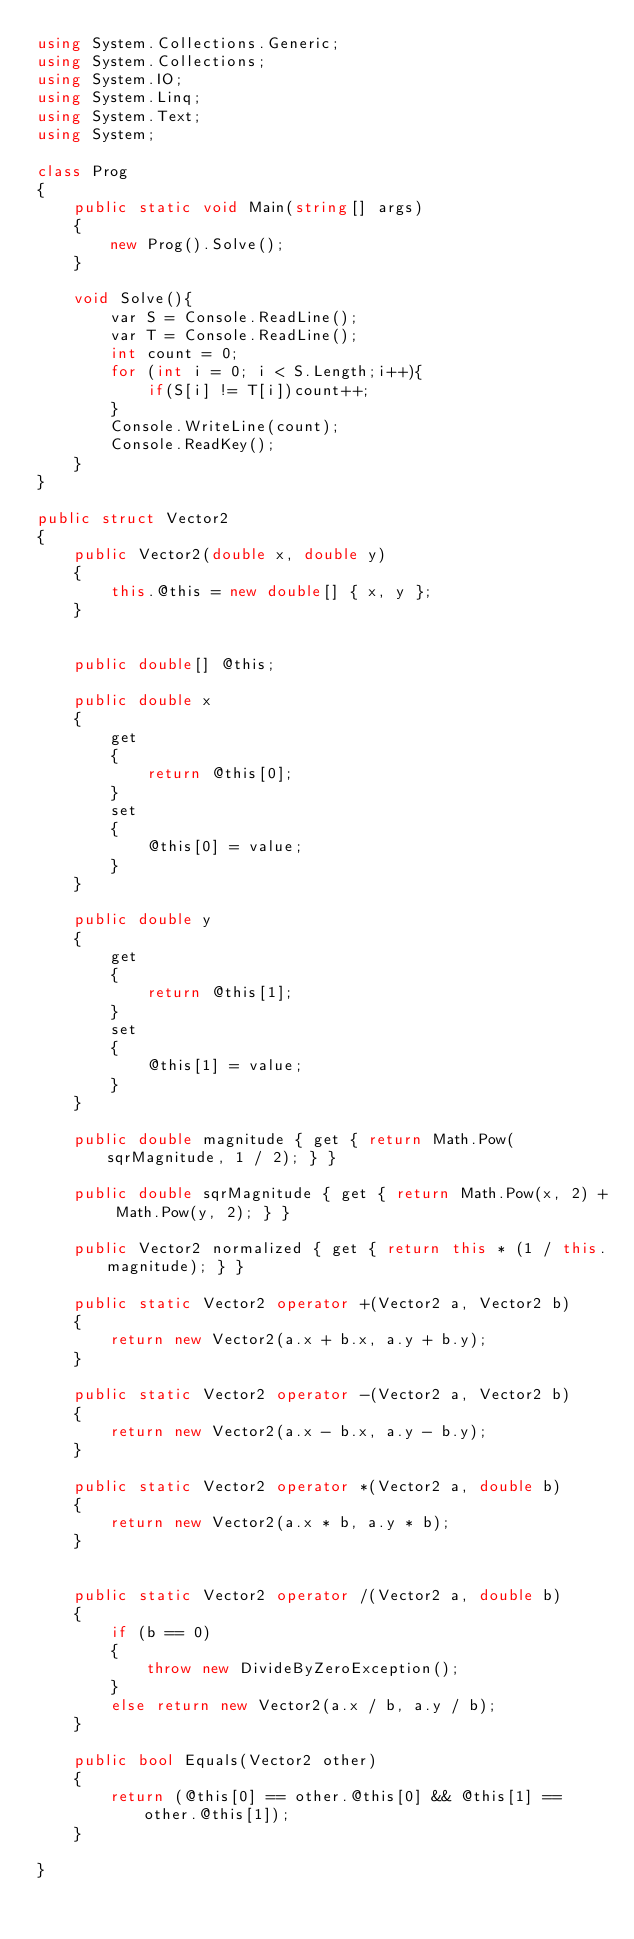<code> <loc_0><loc_0><loc_500><loc_500><_C#_>using System.Collections.Generic;
using System.Collections;
using System.IO;
using System.Linq;
using System.Text;
using System;

class Prog
{
    public static void Main(string[] args)
    {
        new Prog().Solve();
    }

    void Solve(){
        var S = Console.ReadLine();
        var T = Console.ReadLine();
        int count = 0;
        for (int i = 0; i < S.Length;i++){
            if(S[i] != T[i])count++;
        }
        Console.WriteLine(count);
        Console.ReadKey();
    }
}

public struct Vector2
{
    public Vector2(double x, double y)
    {
        this.@this = new double[] { x, y };
    }


    public double[] @this;

    public double x
    {
        get
        {
            return @this[0];
        }
        set
        {
            @this[0] = value;
        }
    }

    public double y
    {
        get
        {
            return @this[1];
        }
        set
        {
            @this[1] = value;
        }
    }

    public double magnitude { get { return Math.Pow(sqrMagnitude, 1 / 2); } }

    public double sqrMagnitude { get { return Math.Pow(x, 2) + Math.Pow(y, 2); } }

    public Vector2 normalized { get { return this * (1 / this.magnitude); } }

    public static Vector2 operator +(Vector2 a, Vector2 b)
    {
        return new Vector2(a.x + b.x, a.y + b.y);
    }

    public static Vector2 operator -(Vector2 a, Vector2 b)
    {
        return new Vector2(a.x - b.x, a.y - b.y);
    }

    public static Vector2 operator *(Vector2 a, double b)
    {
        return new Vector2(a.x * b, a.y * b);
    }


    public static Vector2 operator /(Vector2 a, double b)
    {
        if (b == 0)
        {
            throw new DivideByZeroException();
        }
        else return new Vector2(a.x / b, a.y / b);
    }

    public bool Equals(Vector2 other)
    {
        return (@this[0] == other.@this[0] && @this[1] == other.@this[1]);
    }

}</code> 